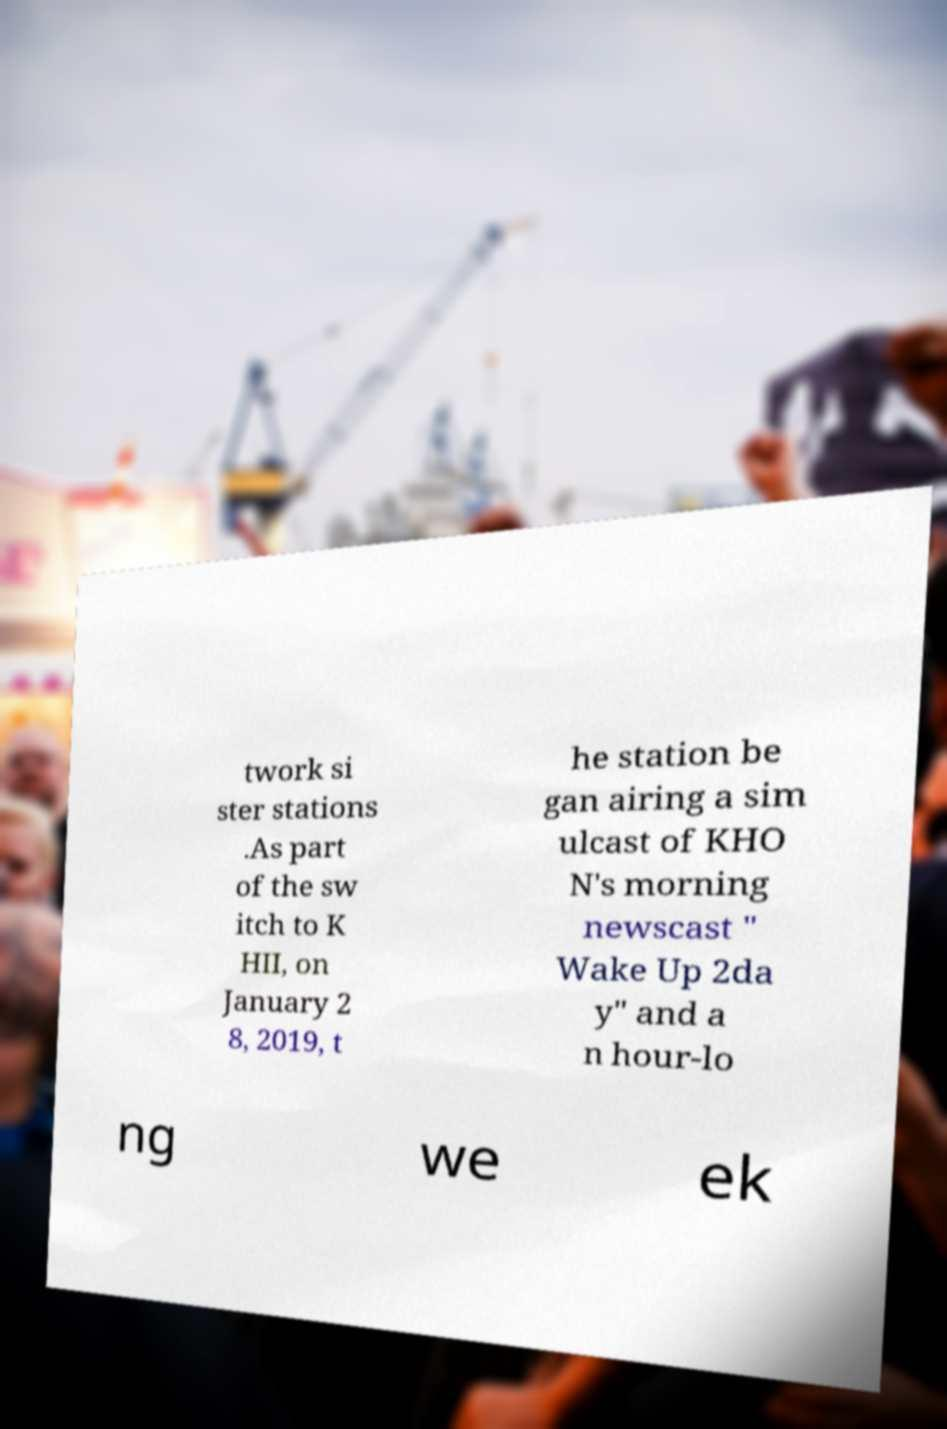Please identify and transcribe the text found in this image. twork si ster stations .As part of the sw itch to K HII, on January 2 8, 2019, t he station be gan airing a sim ulcast of KHO N's morning newscast " Wake Up 2da y" and a n hour-lo ng we ek 